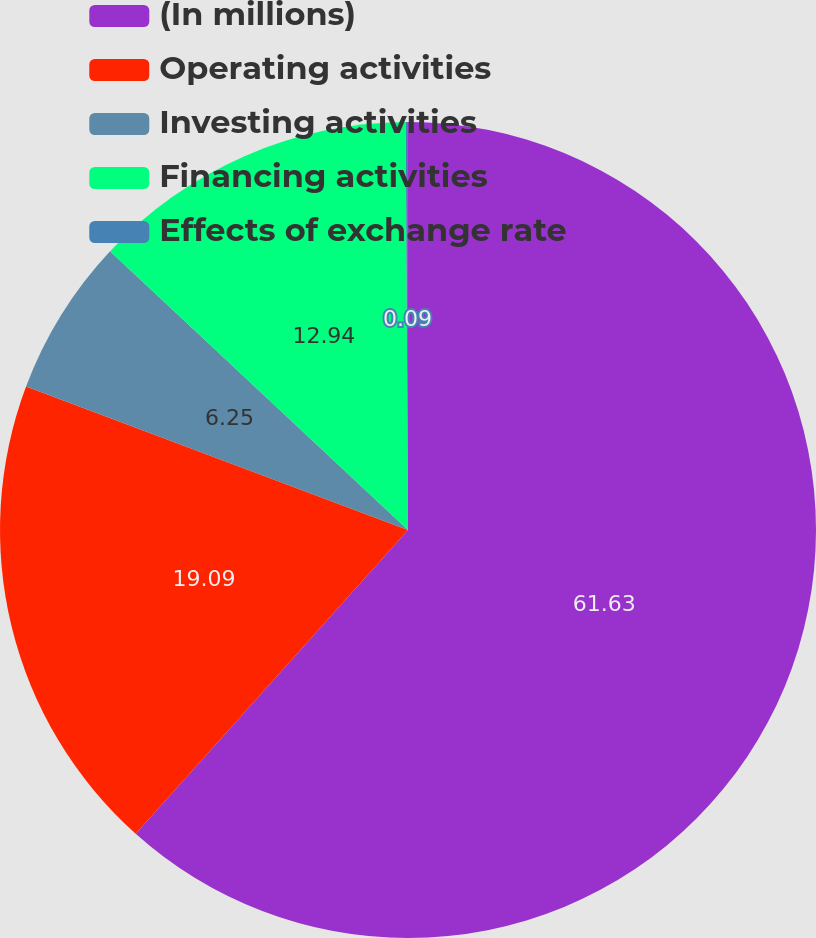Convert chart to OTSL. <chart><loc_0><loc_0><loc_500><loc_500><pie_chart><fcel>(In millions)<fcel>Operating activities<fcel>Investing activities<fcel>Financing activities<fcel>Effects of exchange rate<nl><fcel>61.63%<fcel>19.09%<fcel>6.25%<fcel>12.94%<fcel>0.09%<nl></chart> 